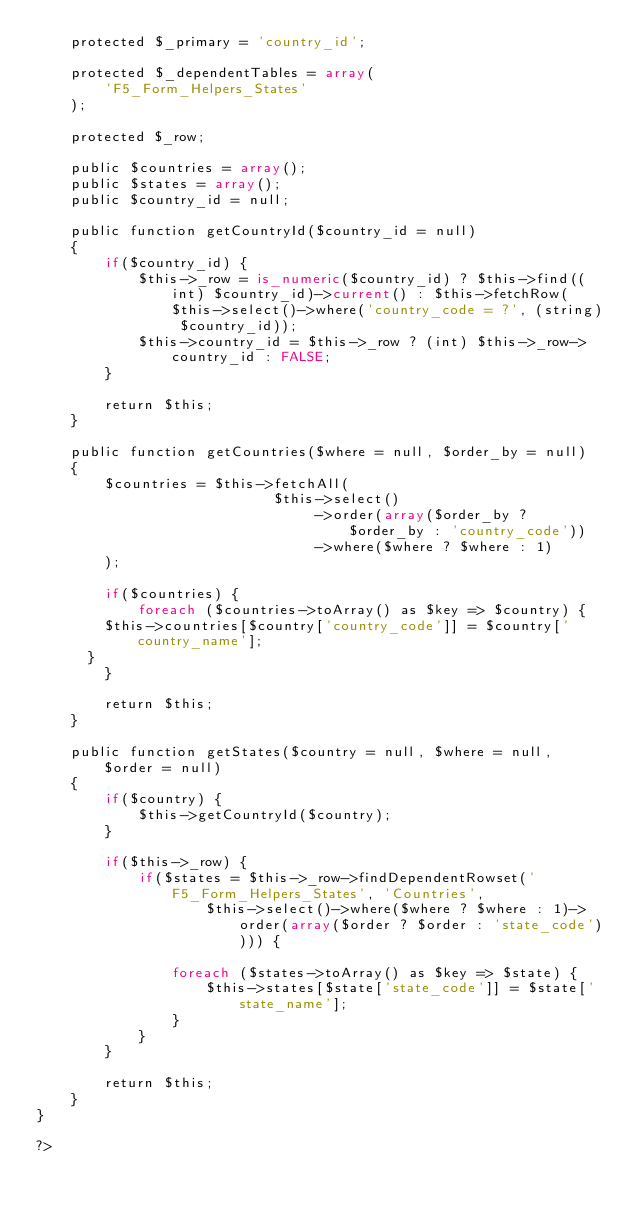<code> <loc_0><loc_0><loc_500><loc_500><_PHP_>    protected $_primary = 'country_id';

    protected $_dependentTables = array(
        'F5_Form_Helpers_States'
    );

    protected $_row;
    
    public $countries = array();
    public $states = array();
    public $country_id = null;

    public function getCountryId($country_id = null)
    {
        if($country_id) {
            $this->_row = is_numeric($country_id) ? $this->find((int) $country_id)->current() : $this->fetchRow($this->select()->where('country_code = ?', (string) $country_id));
            $this->country_id = $this->_row ? (int) $this->_row->country_id : FALSE;
        }
                               
        return $this;
    }
    
    public function getCountries($where = null, $order_by = null)
    {
        $countries = $this->fetchAll(
                            $this->select()
                                 ->order(array($order_by ? $order_by : 'country_code'))
                                 ->where($where ? $where : 1)
        );
        
        if($countries) {            
            foreach ($countries->toArray() as $key => $country) {
				$this->countries[$country['country_code']] = $country['country_name'];
			}
        }
 
        return $this;        
    }

    public function getStates($country = null, $where = null, $order = null)
    {
        if($country) {
            $this->getCountryId($country);
        }
        
        if($this->_row) {               
            if($states = $this->_row->findDependentRowset('F5_Form_Helpers_States', 'Countries',
                    $this->select()->where($where ? $where : 1)->order(array($order ? $order : 'state_code')))) {
                        
                foreach ($states->toArray() as $key => $state) {
                    $this->states[$state['state_code']] = $state['state_name'];
                }
            }
        }

        return $this;
    }
}
    
?></code> 